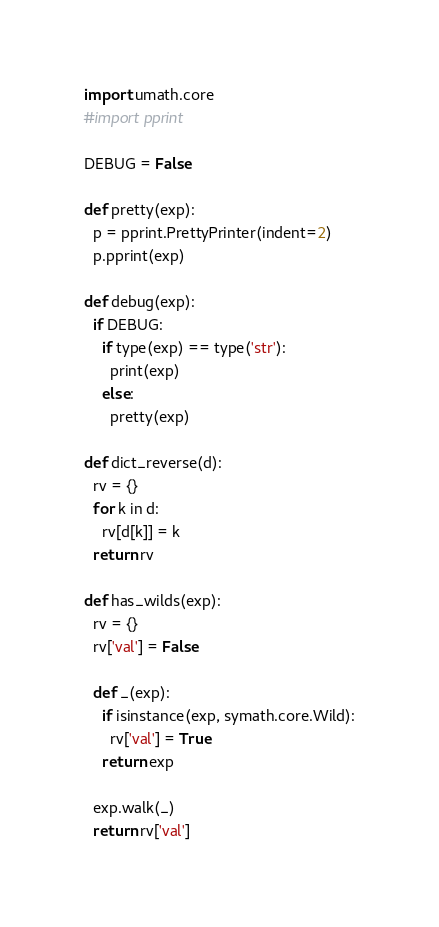Convert code to text. <code><loc_0><loc_0><loc_500><loc_500><_Python_>import umath.core
#import pprint

DEBUG = False

def pretty(exp):
  p = pprint.PrettyPrinter(indent=2)
  p.pprint(exp)

def debug(exp):
  if DEBUG:
    if type(exp) == type('str'):
      print(exp)
    else:
      pretty(exp)

def dict_reverse(d):
  rv = {}
  for k in d:
    rv[d[k]] = k
  return rv

def has_wilds(exp):
  rv = {}
  rv['val'] = False

  def _(exp):
    if isinstance(exp, symath.core.Wild):
      rv['val'] = True
    return exp

  exp.walk(_)
  return rv['val']

</code> 